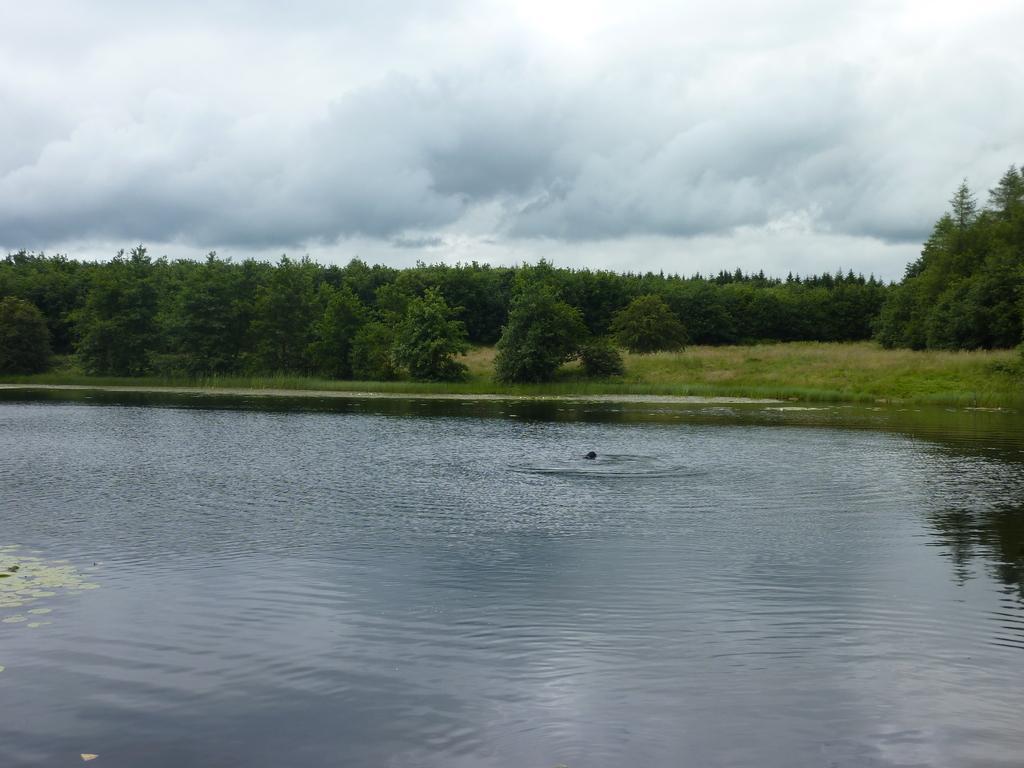Describe this image in one or two sentences. In this image I can see few green color trees and water. The sky is in white and blue color. 